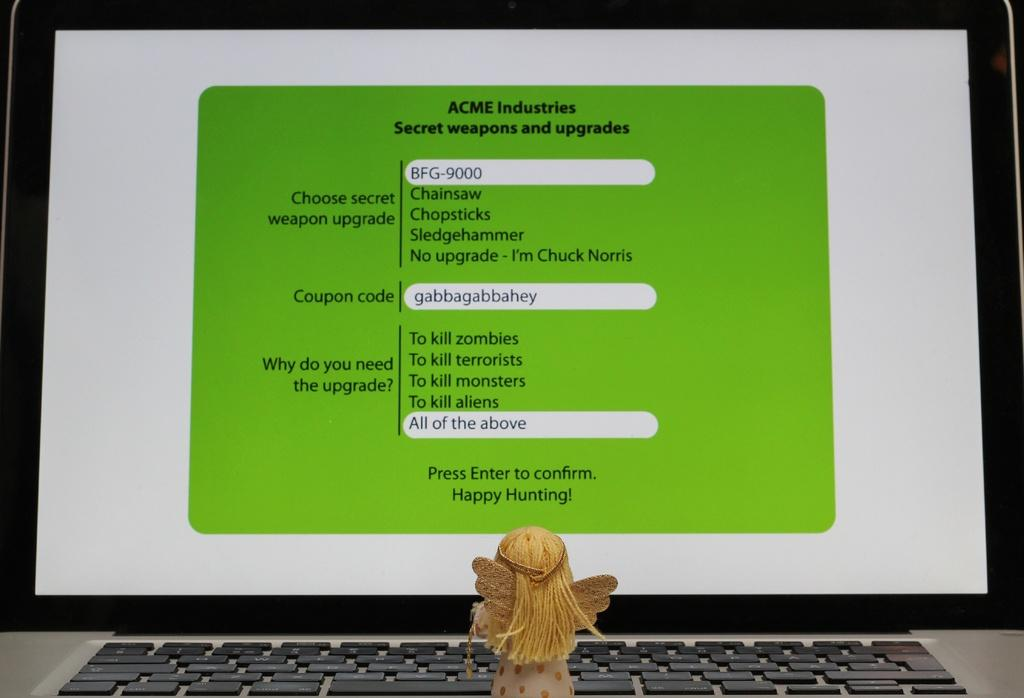<image>
Summarize the visual content of the image. If you require secret weapons and upgrades, then ACME Industries is the place to get them. 